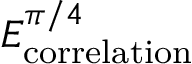Convert formula to latex. <formula><loc_0><loc_0><loc_500><loc_500>E _ { c o r r e l a t i o n } ^ { \pi / 4 }</formula> 